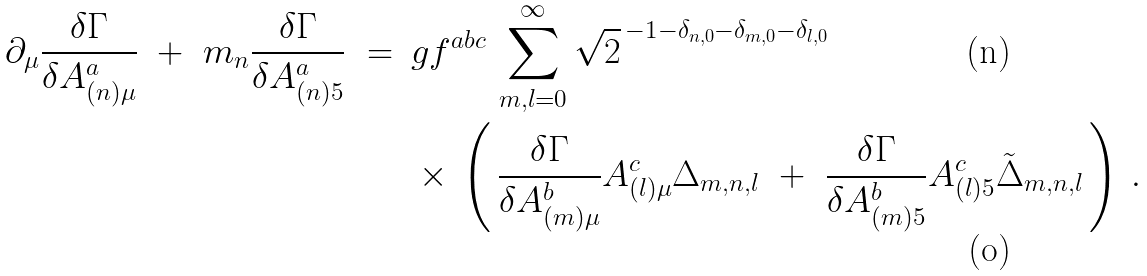Convert formula to latex. <formula><loc_0><loc_0><loc_500><loc_500>\partial _ { \mu } \frac { \delta \Gamma } { \delta A ^ { a } _ { ( n ) \mu } } \ + \ m _ { n } \frac { \delta \Gamma } { \delta A ^ { a } _ { ( n ) 5 } } \ = \ \, & g f ^ { a b c } \, \sum _ { m , l = 0 } ^ { \infty } \sqrt { 2 } ^ { \, - 1 - \delta _ { n , 0 } - \delta _ { m , 0 } - \delta _ { l , 0 } } \\ & \times \, \left ( \, \frac { \delta \Gamma } { \delta A ^ { b } _ { ( m ) \mu } } A ^ { c } _ { ( l ) \mu } \Delta _ { m , n , l } \ + \ \frac { \delta \Gamma } { \delta A ^ { b } _ { ( m ) 5 } } A ^ { c } _ { ( l ) 5 } \tilde { \Delta } _ { m , n , l } \, \right ) \, .</formula> 